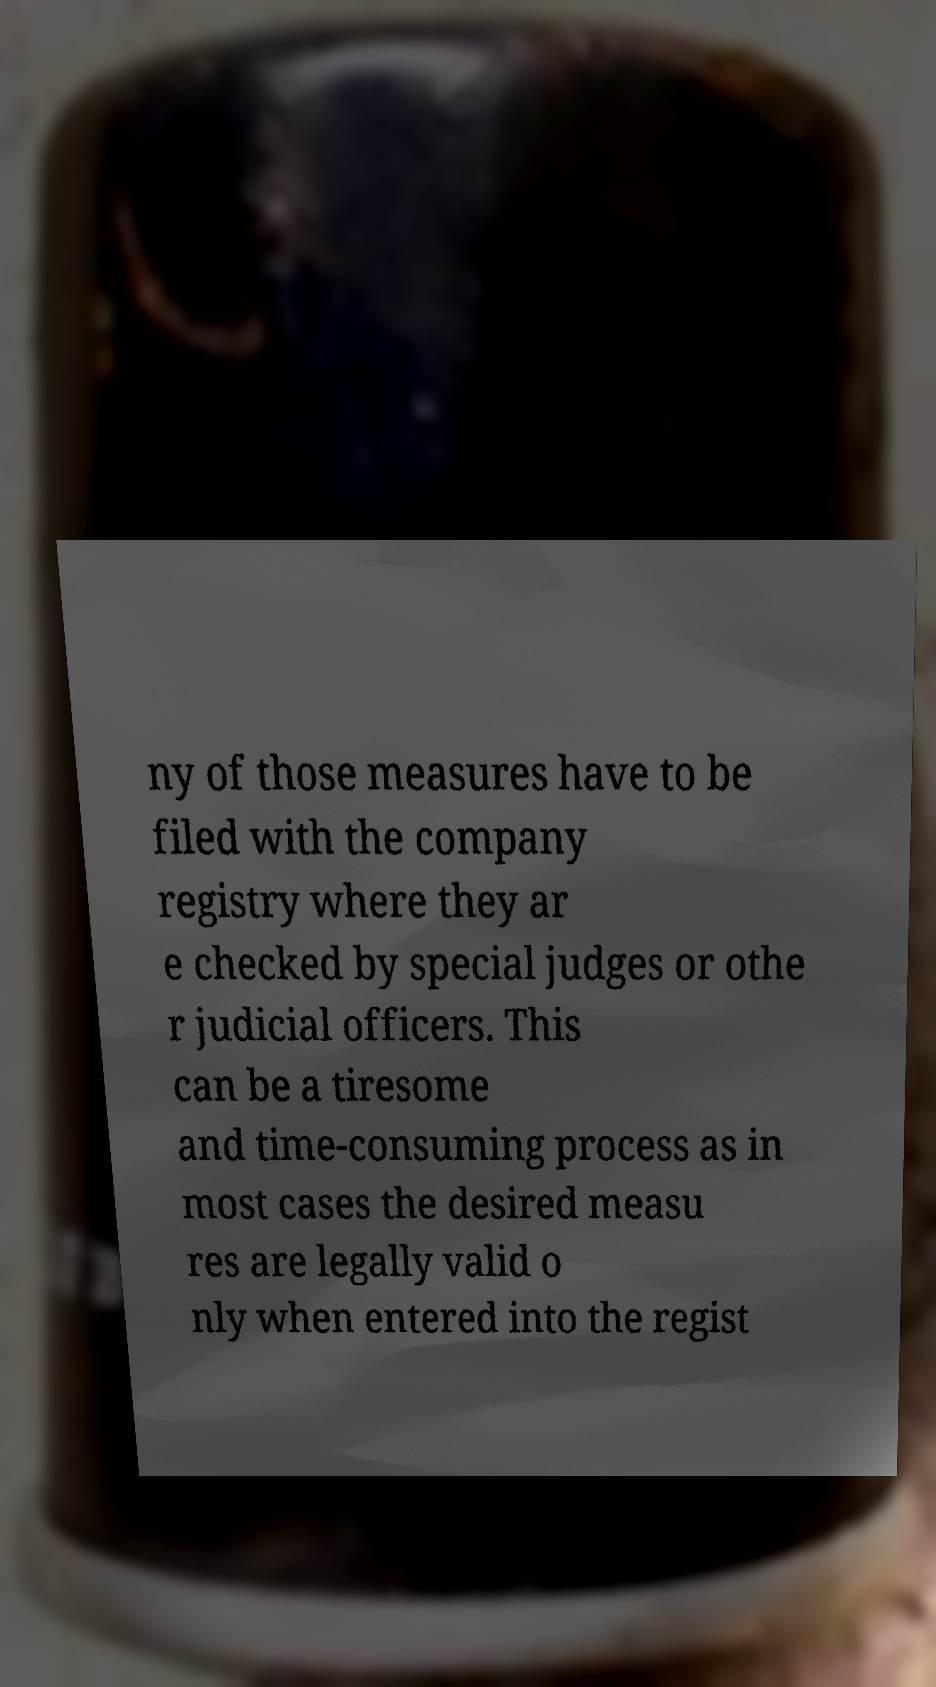Please read and relay the text visible in this image. What does it say? ny of those measures have to be filed with the company registry where they ar e checked by special judges or othe r judicial officers. This can be a tiresome and time-consuming process as in most cases the desired measu res are legally valid o nly when entered into the regist 